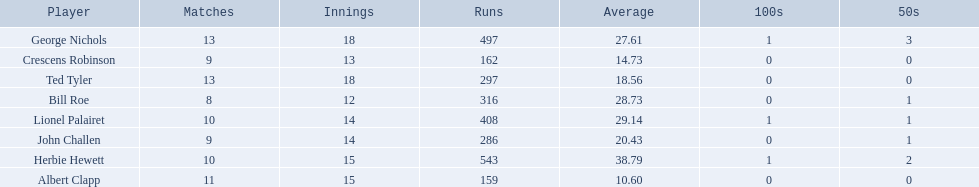Who are all of the players? Herbie Hewett, Lionel Palairet, Bill Roe, George Nichols, John Challen, Ted Tyler, Crescens Robinson, Albert Clapp. How many innings did they play in? 15, 14, 12, 18, 14, 18, 13, 15. Which player was in fewer than 13 innings? Bill Roe. 